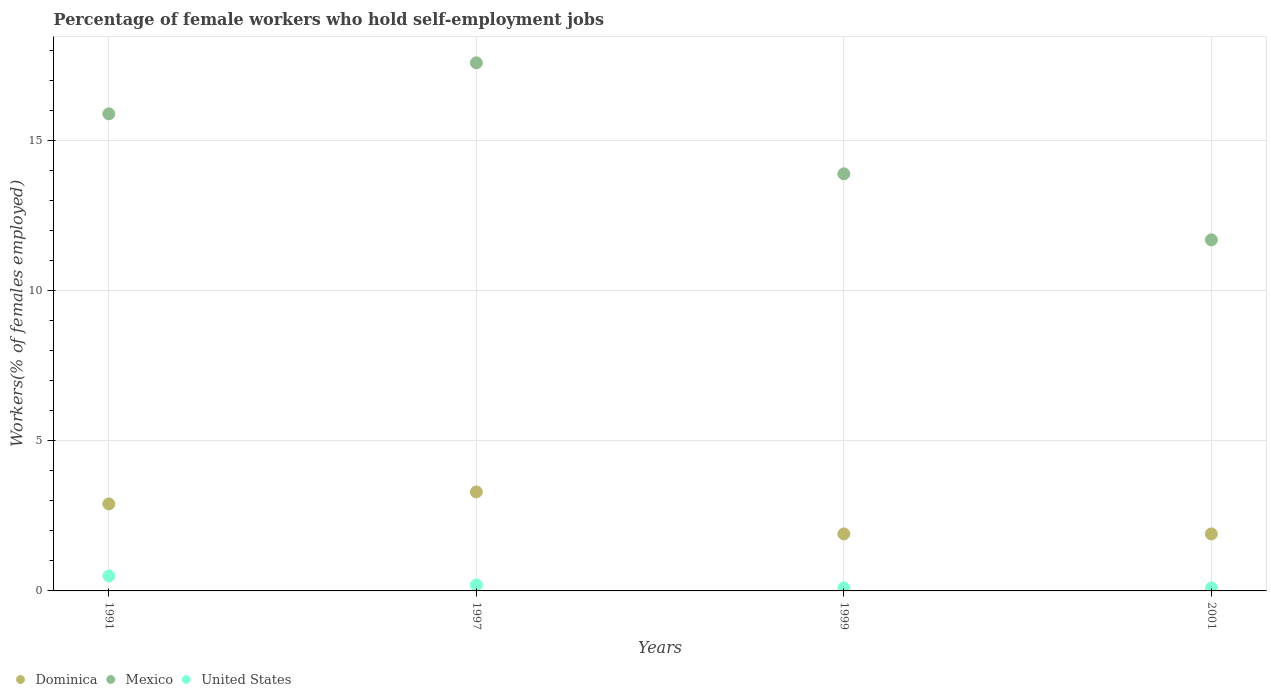Is the number of dotlines equal to the number of legend labels?
Offer a very short reply. Yes. What is the percentage of self-employed female workers in Mexico in 1991?
Make the answer very short. 15.9. Across all years, what is the maximum percentage of self-employed female workers in Mexico?
Provide a short and direct response. 17.6. Across all years, what is the minimum percentage of self-employed female workers in Mexico?
Ensure brevity in your answer.  11.7. In which year was the percentage of self-employed female workers in United States minimum?
Provide a succinct answer. 1999. What is the total percentage of self-employed female workers in United States in the graph?
Your answer should be compact. 0.9. What is the difference between the percentage of self-employed female workers in Mexico in 1997 and that in 1999?
Offer a terse response. 3.7. What is the difference between the percentage of self-employed female workers in Dominica in 1991 and the percentage of self-employed female workers in United States in 2001?
Offer a terse response. 2.8. What is the average percentage of self-employed female workers in Dominica per year?
Ensure brevity in your answer.  2.5. In the year 1997, what is the difference between the percentage of self-employed female workers in Mexico and percentage of self-employed female workers in Dominica?
Ensure brevity in your answer.  14.3. In how many years, is the percentage of self-employed female workers in Dominica greater than 16 %?
Your answer should be compact. 0. What is the ratio of the percentage of self-employed female workers in United States in 1991 to that in 2001?
Provide a short and direct response. 5. What is the difference between the highest and the second highest percentage of self-employed female workers in Mexico?
Your answer should be compact. 1.7. What is the difference between the highest and the lowest percentage of self-employed female workers in United States?
Give a very brief answer. 0.4. Is the sum of the percentage of self-employed female workers in United States in 1999 and 2001 greater than the maximum percentage of self-employed female workers in Mexico across all years?
Give a very brief answer. No. Does the percentage of self-employed female workers in United States monotonically increase over the years?
Ensure brevity in your answer.  No. Is the percentage of self-employed female workers in Dominica strictly greater than the percentage of self-employed female workers in Mexico over the years?
Keep it short and to the point. No. Is the percentage of self-employed female workers in United States strictly less than the percentage of self-employed female workers in Mexico over the years?
Offer a terse response. Yes. Are the values on the major ticks of Y-axis written in scientific E-notation?
Keep it short and to the point. No. Does the graph contain grids?
Offer a terse response. Yes. Where does the legend appear in the graph?
Give a very brief answer. Bottom left. How many legend labels are there?
Provide a succinct answer. 3. How are the legend labels stacked?
Your response must be concise. Horizontal. What is the title of the graph?
Your response must be concise. Percentage of female workers who hold self-employment jobs. What is the label or title of the X-axis?
Ensure brevity in your answer.  Years. What is the label or title of the Y-axis?
Provide a short and direct response. Workers(% of females employed). What is the Workers(% of females employed) in Dominica in 1991?
Give a very brief answer. 2.9. What is the Workers(% of females employed) in Mexico in 1991?
Provide a short and direct response. 15.9. What is the Workers(% of females employed) of Dominica in 1997?
Ensure brevity in your answer.  3.3. What is the Workers(% of females employed) in Mexico in 1997?
Provide a succinct answer. 17.6. What is the Workers(% of females employed) in United States in 1997?
Give a very brief answer. 0.2. What is the Workers(% of females employed) in Dominica in 1999?
Your answer should be compact. 1.9. What is the Workers(% of females employed) of Mexico in 1999?
Ensure brevity in your answer.  13.9. What is the Workers(% of females employed) in United States in 1999?
Provide a short and direct response. 0.1. What is the Workers(% of females employed) of Dominica in 2001?
Ensure brevity in your answer.  1.9. What is the Workers(% of females employed) in Mexico in 2001?
Make the answer very short. 11.7. What is the Workers(% of females employed) of United States in 2001?
Your response must be concise. 0.1. Across all years, what is the maximum Workers(% of females employed) in Dominica?
Ensure brevity in your answer.  3.3. Across all years, what is the maximum Workers(% of females employed) of Mexico?
Offer a terse response. 17.6. Across all years, what is the maximum Workers(% of females employed) of United States?
Ensure brevity in your answer.  0.5. Across all years, what is the minimum Workers(% of females employed) in Dominica?
Your response must be concise. 1.9. Across all years, what is the minimum Workers(% of females employed) in Mexico?
Offer a terse response. 11.7. Across all years, what is the minimum Workers(% of females employed) of United States?
Make the answer very short. 0.1. What is the total Workers(% of females employed) in Mexico in the graph?
Keep it short and to the point. 59.1. What is the difference between the Workers(% of females employed) of Mexico in 1991 and that in 1999?
Offer a terse response. 2. What is the difference between the Workers(% of females employed) in United States in 1991 and that in 1999?
Give a very brief answer. 0.4. What is the difference between the Workers(% of females employed) of Mexico in 1991 and that in 2001?
Give a very brief answer. 4.2. What is the difference between the Workers(% of females employed) of Dominica in 1997 and that in 2001?
Your answer should be very brief. 1.4. What is the difference between the Workers(% of females employed) of Mexico in 1997 and that in 2001?
Your answer should be very brief. 5.9. What is the difference between the Workers(% of females employed) in United States in 1997 and that in 2001?
Make the answer very short. 0.1. What is the difference between the Workers(% of females employed) of Mexico in 1999 and that in 2001?
Your answer should be compact. 2.2. What is the difference between the Workers(% of females employed) in Dominica in 1991 and the Workers(% of females employed) in Mexico in 1997?
Give a very brief answer. -14.7. What is the difference between the Workers(% of females employed) in Dominica in 1991 and the Workers(% of females employed) in United States in 1997?
Your answer should be very brief. 2.7. What is the difference between the Workers(% of females employed) in Dominica in 1991 and the Workers(% of females employed) in United States in 1999?
Offer a very short reply. 2.8. What is the difference between the Workers(% of females employed) of Mexico in 1991 and the Workers(% of females employed) of United States in 1999?
Offer a very short reply. 15.8. What is the difference between the Workers(% of females employed) in Dominica in 1997 and the Workers(% of females employed) in Mexico in 1999?
Make the answer very short. -10.6. What is the difference between the Workers(% of females employed) of Mexico in 1997 and the Workers(% of females employed) of United States in 1999?
Make the answer very short. 17.5. What is the difference between the Workers(% of females employed) of Dominica in 1997 and the Workers(% of females employed) of United States in 2001?
Keep it short and to the point. 3.2. What is the difference between the Workers(% of females employed) in Mexico in 1999 and the Workers(% of females employed) in United States in 2001?
Provide a short and direct response. 13.8. What is the average Workers(% of females employed) in Dominica per year?
Ensure brevity in your answer.  2.5. What is the average Workers(% of females employed) of Mexico per year?
Offer a very short reply. 14.78. What is the average Workers(% of females employed) of United States per year?
Your answer should be very brief. 0.23. In the year 1991, what is the difference between the Workers(% of females employed) in Dominica and Workers(% of females employed) in Mexico?
Your response must be concise. -13. In the year 1991, what is the difference between the Workers(% of females employed) of Dominica and Workers(% of females employed) of United States?
Offer a terse response. 2.4. In the year 1991, what is the difference between the Workers(% of females employed) in Mexico and Workers(% of females employed) in United States?
Keep it short and to the point. 15.4. In the year 1997, what is the difference between the Workers(% of females employed) of Dominica and Workers(% of females employed) of Mexico?
Keep it short and to the point. -14.3. In the year 1997, what is the difference between the Workers(% of females employed) in Mexico and Workers(% of females employed) in United States?
Ensure brevity in your answer.  17.4. In the year 1999, what is the difference between the Workers(% of females employed) of Dominica and Workers(% of females employed) of Mexico?
Ensure brevity in your answer.  -12. In the year 2001, what is the difference between the Workers(% of females employed) of Dominica and Workers(% of females employed) of United States?
Ensure brevity in your answer.  1.8. What is the ratio of the Workers(% of females employed) of Dominica in 1991 to that in 1997?
Give a very brief answer. 0.88. What is the ratio of the Workers(% of females employed) of Mexico in 1991 to that in 1997?
Keep it short and to the point. 0.9. What is the ratio of the Workers(% of females employed) of Dominica in 1991 to that in 1999?
Give a very brief answer. 1.53. What is the ratio of the Workers(% of females employed) in Mexico in 1991 to that in 1999?
Provide a short and direct response. 1.14. What is the ratio of the Workers(% of females employed) of Dominica in 1991 to that in 2001?
Offer a very short reply. 1.53. What is the ratio of the Workers(% of females employed) in Mexico in 1991 to that in 2001?
Provide a succinct answer. 1.36. What is the ratio of the Workers(% of females employed) in United States in 1991 to that in 2001?
Your response must be concise. 5. What is the ratio of the Workers(% of females employed) in Dominica in 1997 to that in 1999?
Keep it short and to the point. 1.74. What is the ratio of the Workers(% of females employed) in Mexico in 1997 to that in 1999?
Offer a very short reply. 1.27. What is the ratio of the Workers(% of females employed) of Dominica in 1997 to that in 2001?
Provide a short and direct response. 1.74. What is the ratio of the Workers(% of females employed) in Mexico in 1997 to that in 2001?
Your answer should be very brief. 1.5. What is the ratio of the Workers(% of females employed) of United States in 1997 to that in 2001?
Keep it short and to the point. 2. What is the ratio of the Workers(% of females employed) of Dominica in 1999 to that in 2001?
Your answer should be very brief. 1. What is the ratio of the Workers(% of females employed) in Mexico in 1999 to that in 2001?
Your answer should be very brief. 1.19. What is the difference between the highest and the second highest Workers(% of females employed) in Dominica?
Make the answer very short. 0.4. What is the difference between the highest and the second highest Workers(% of females employed) of United States?
Your response must be concise. 0.3. What is the difference between the highest and the lowest Workers(% of females employed) of Mexico?
Provide a succinct answer. 5.9. 